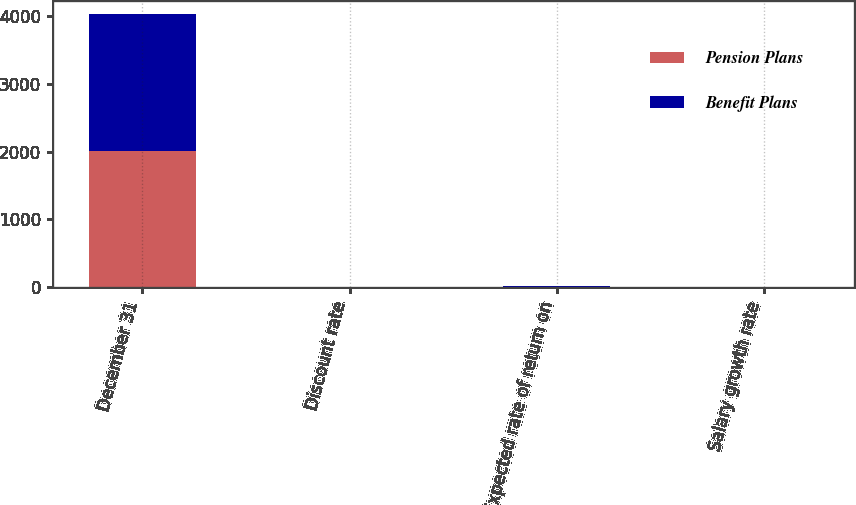Convert chart. <chart><loc_0><loc_0><loc_500><loc_500><stacked_bar_chart><ecel><fcel>December 31<fcel>Discount rate<fcel>Expected rate of return on<fcel>Salary growth rate<nl><fcel>Pension Plans<fcel>2009<fcel>5.8<fcel>7.9<fcel>4.3<nl><fcel>Benefit Plans<fcel>2009<fcel>6.15<fcel>8.75<fcel>4.5<nl></chart> 